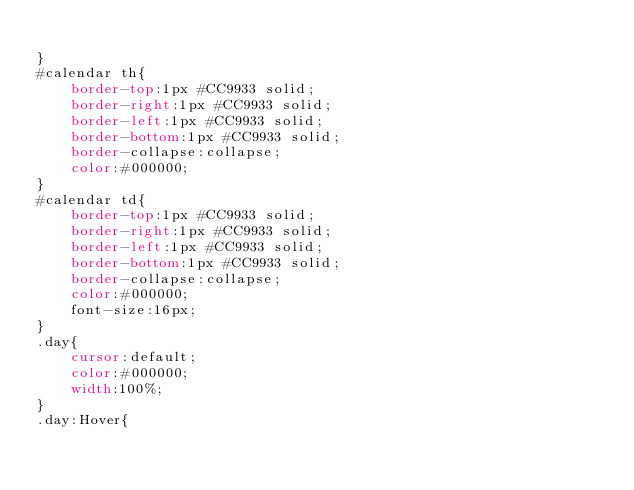<code> <loc_0><loc_0><loc_500><loc_500><_CSS_>
}
#calendar th{
    border-top:1px #CC9933 solid;
    border-right:1px #CC9933 solid;
    border-left:1px #CC9933 solid;
    border-bottom:1px #CC9933 solid;
    border-collapse:collapse;
    color:#000000;			
}
#calendar td{
    border-top:1px #CC9933 solid;
    border-right:1px #CC9933 solid;
    border-left:1px #CC9933 solid;
    border-bottom:1px #CC9933 solid;
    border-collapse:collapse;
    color:#000000;
    font-size:16px;
}
.day{
    cursor:default;
    color:#000000;
    width:100%;
}
.day:Hover{</code> 